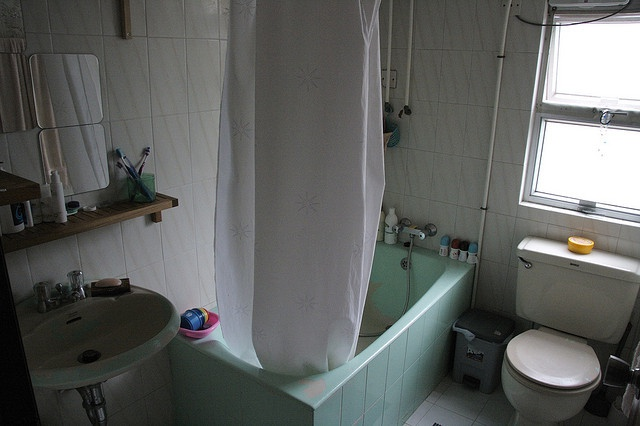Describe the objects in this image and their specific colors. I can see toilet in black, gray, darkgray, and lightgray tones, sink in black and gray tones, cup in black, gray, teal, and darkgreen tones, bottle in black and gray tones, and bottle in black and gray tones in this image. 